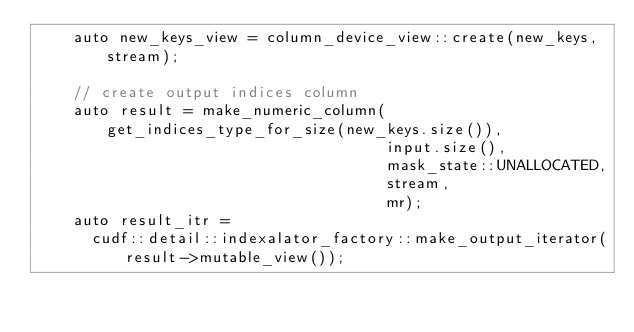<code> <loc_0><loc_0><loc_500><loc_500><_Cuda_>    auto new_keys_view = column_device_view::create(new_keys, stream);

    // create output indices column
    auto result = make_numeric_column(get_indices_type_for_size(new_keys.size()),
                                      input.size(),
                                      mask_state::UNALLOCATED,
                                      stream,
                                      mr);
    auto result_itr =
      cudf::detail::indexalator_factory::make_output_iterator(result->mutable_view());</code> 